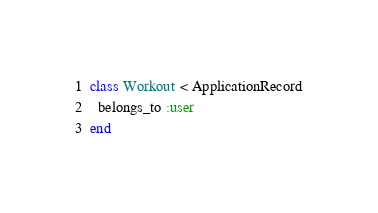Convert code to text. <code><loc_0><loc_0><loc_500><loc_500><_Ruby_>class Workout < ApplicationRecord
  belongs_to :user
end
</code> 